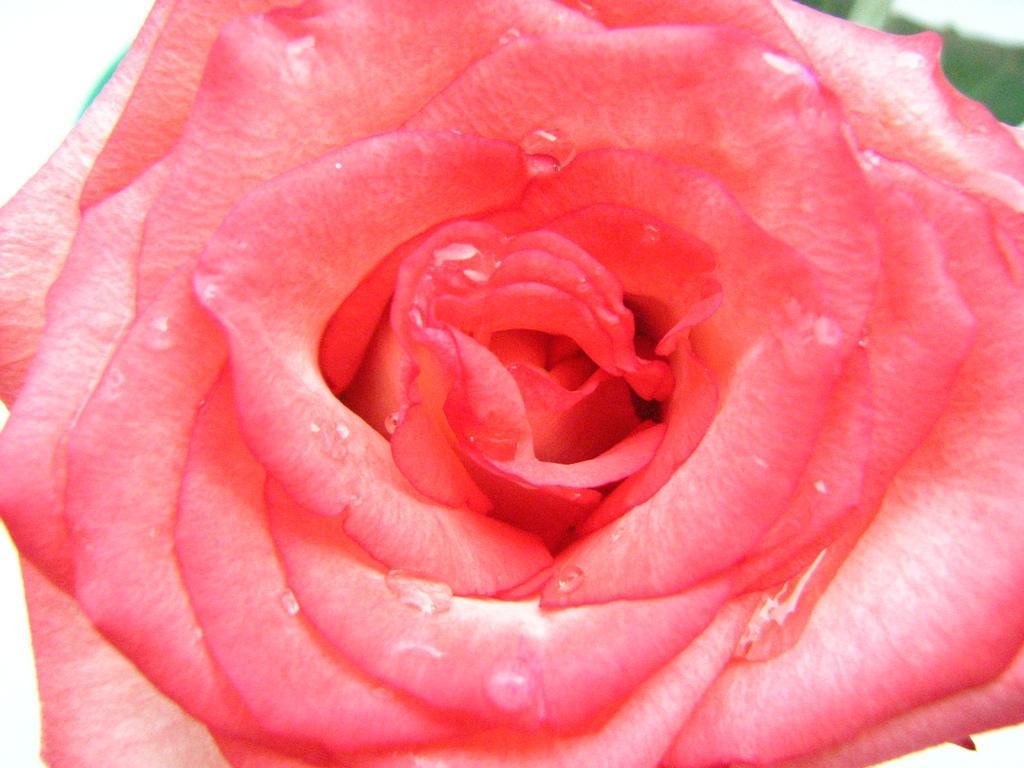Can you describe this image briefly? In this picture we can see a flower. 